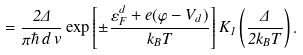<formula> <loc_0><loc_0><loc_500><loc_500>= \frac { 2 \Delta } { \pi \hbar { \, } d \, v } \exp \left [ \pm \frac { \varepsilon _ { F } ^ { d } + e ( \varphi - V _ { d } ) } { k _ { B } T } \right ] K _ { 1 } \left ( \frac { \Delta } { 2 k _ { B } T } \right ) .</formula> 